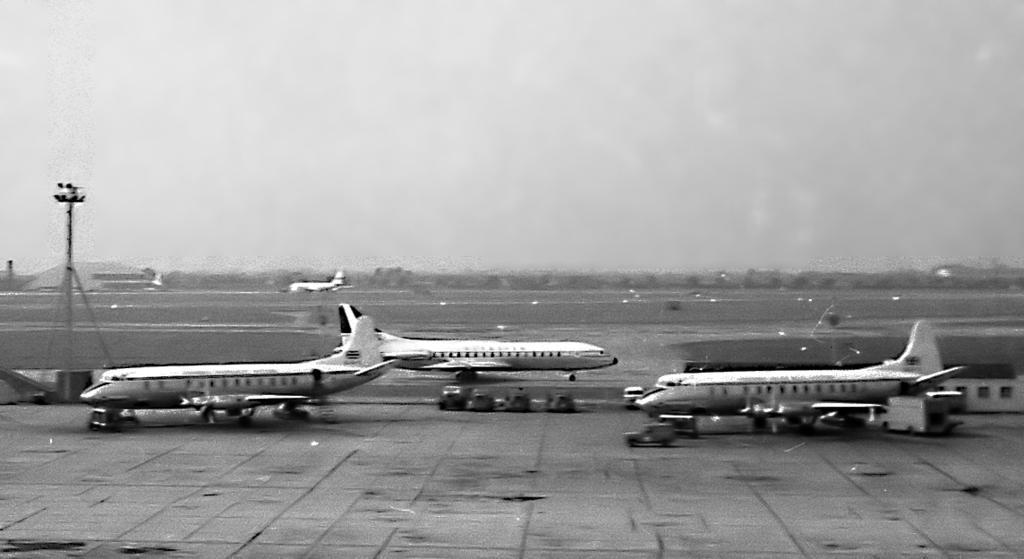Please provide a concise description of this image. In this image there are four airplanes on the runway , there are vehicles, pole, lights, trees, buildings, sky. 